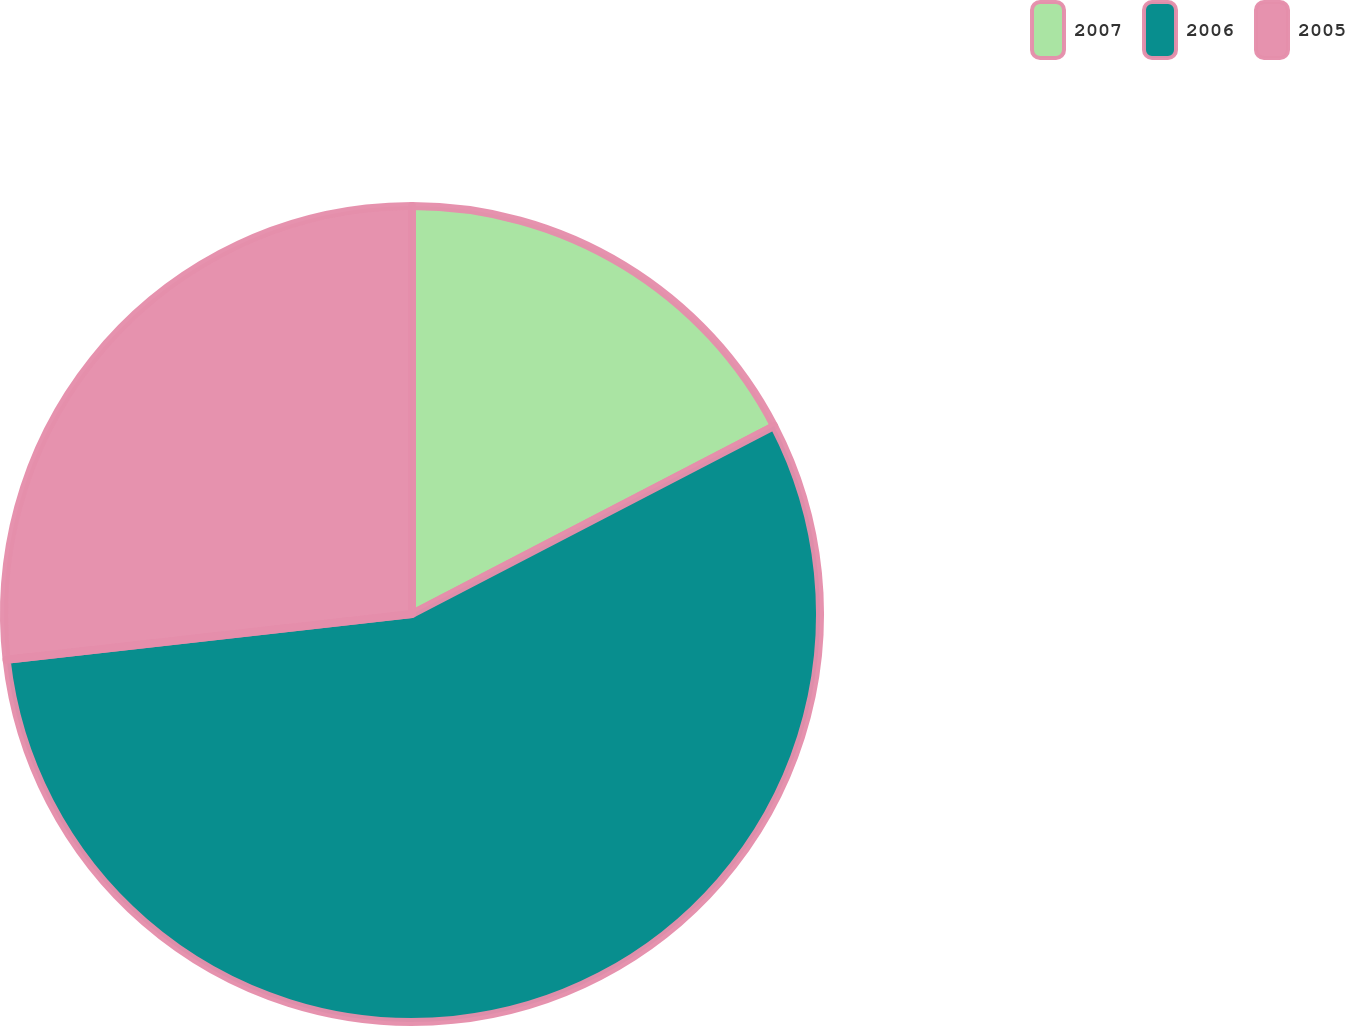<chart> <loc_0><loc_0><loc_500><loc_500><pie_chart><fcel>2007<fcel>2006<fcel>2005<nl><fcel>17.38%<fcel>55.83%<fcel>26.79%<nl></chart> 